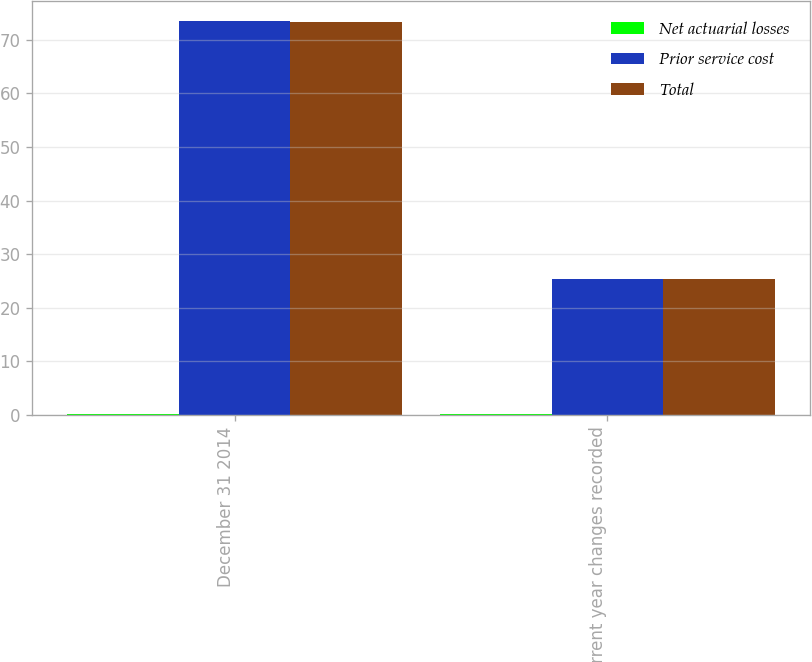Convert chart. <chart><loc_0><loc_0><loc_500><loc_500><stacked_bar_chart><ecel><fcel>December 31 2014<fcel>Current year changes recorded<nl><fcel>Net actuarial losses<fcel>0.1<fcel>0.1<nl><fcel>Prior service cost<fcel>73.5<fcel>25.3<nl><fcel>Total<fcel>73.4<fcel>25.4<nl></chart> 